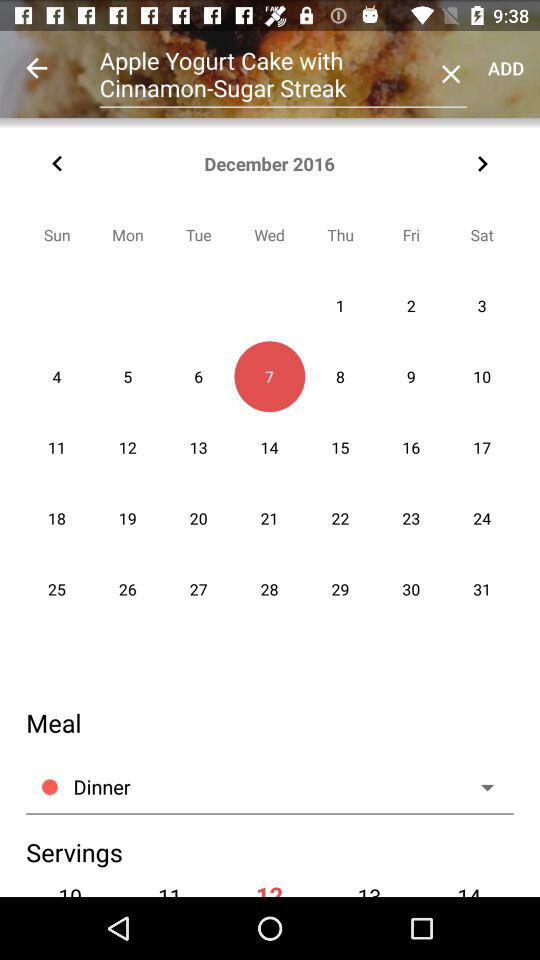How many people servings here?
When the provided information is insufficient, respond with <no answer>. <no answer> 